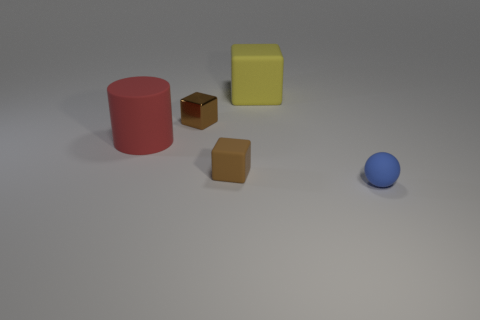Add 5 small blocks. How many objects exist? 10 Subtract all blocks. How many objects are left? 2 Add 4 big red things. How many big red things are left? 5 Add 2 large blue cubes. How many large blue cubes exist? 2 Subtract 0 green cylinders. How many objects are left? 5 Subtract all small purple rubber things. Subtract all matte cylinders. How many objects are left? 4 